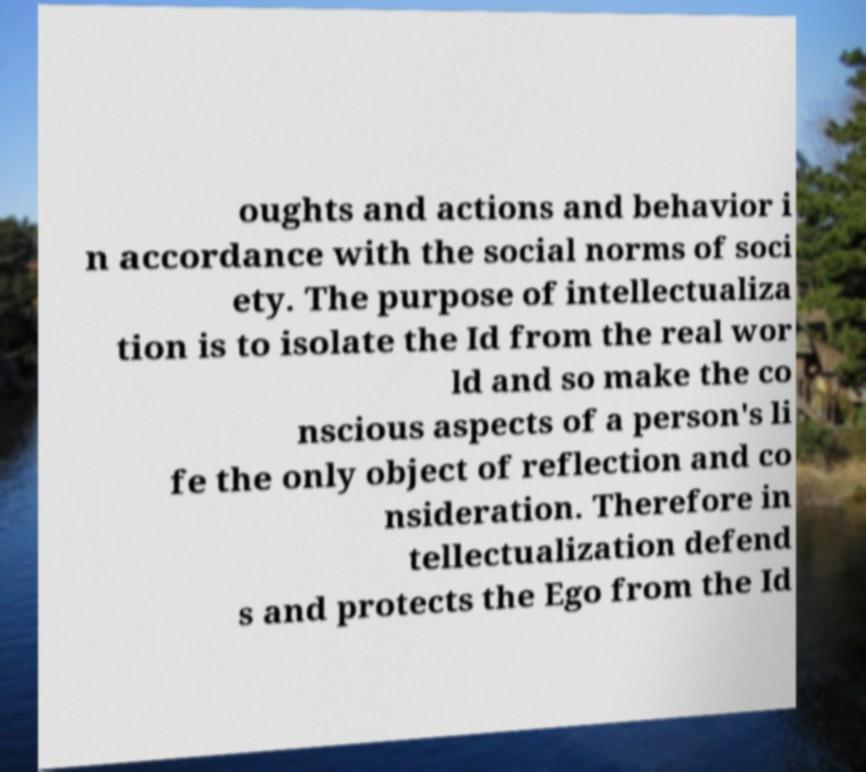Please read and relay the text visible in this image. What does it say? oughts and actions and behavior i n accordance with the social norms of soci ety. The purpose of intellectualiza tion is to isolate the Id from the real wor ld and so make the co nscious aspects of a person's li fe the only object of reflection and co nsideration. Therefore in tellectualization defend s and protects the Ego from the Id 